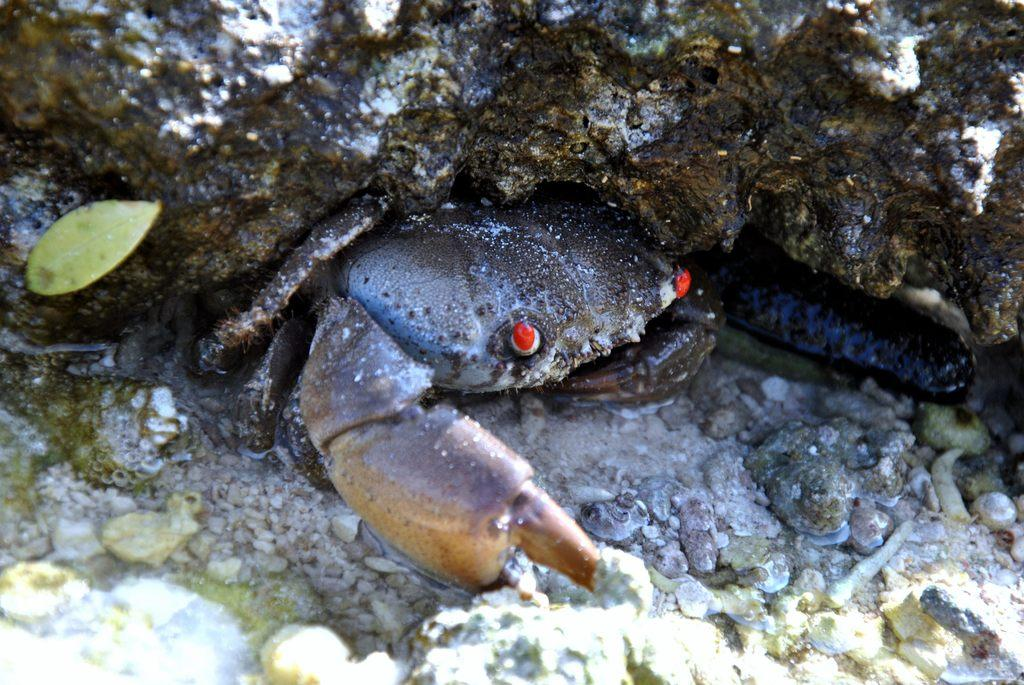What animal can be seen in the water in the image? There is a crab in the water in the image. What type of natural objects are present in the image? There are stones, a leaf, and a rock in the image. Can you describe the setting of the image? The image was likely taken during the day, as there is no indication of darkness or artificial lighting. What type of oven can be seen in the image? There is no oven present in the image; it features a crab in the water and natural objects like stones, a leaf, and a rock. Can you describe the argument taking place between the crab and the leaf in the image? There is no argument depicted in the image; it simply shows a crab in the water and the mentioned natural objects. 